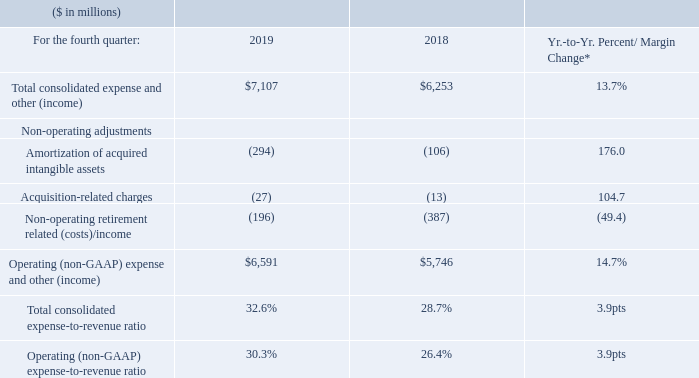* 2019 results were impacted by Red Hat purchase accounting and acquisition-related activity.
Total expense and other (income) increased 13.7 percent in the fourth quarter with an expense-to-revenue ratio of 32.6 percent compared to 28.7 percent in the fourth quarter of 2018. The year-to-year increase was a result of higher spending (15 points) driven by Red Hat (15 points) and higher acquisitionrelated charges and amortization of acquired intangible assets associated with the Red Hat transaction (4 points), partially offset by higher divestiture gains (3 points) and lower non-operating retirement-related costs (3 points).
Total operating (non-GAAP) expense and other income increased 14.7 percent year to year primarily driven by the higher spending, partially offset by the divestiture gains, as described above.
What event impacted the 2019 results? 2019 results were impacted by red hat purchase accounting and acquisition-related activity. What caused the year-to-year increase in the total expenses and other (income)? The year-to-year increase was a result of higher spending (15 points) driven by red hat (15 points) and higher acquisitionrelated charges and amortization of acquired intangible assets associated with the red hat transaction (4 points), partially offset by higher divestiture gains (3 points) and lower non-operating retirement-related costs (3 points). What caused total operating (non-GAAP) expense and other income to increase? Driven by the higher spending, partially offset by the divestiture gains, as described above. What was the increase / (decrease) in Total consolidated expense and other (income) from 2018 to 2019?
Answer scale should be: million. 7,107 - 6,253
Answer: 854. What is the average Amortization of acquired intangible assets?
Answer scale should be: million. ( - 294 + (- 106)) / 2
Answer: -200. What is the average of Operating (non-GAAP) expense and other (income)?
Answer scale should be: million. (6,591 + 5,746) / 2
Answer: 6168.5. 